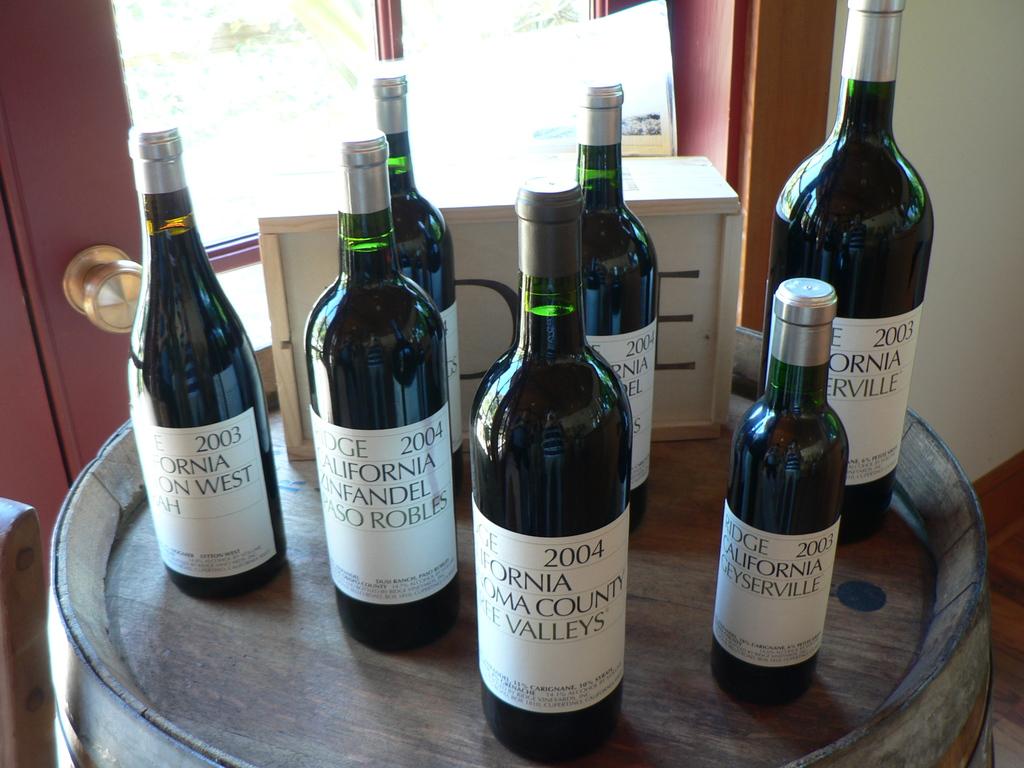What does the text say on the bottle?
Offer a terse response. California. 